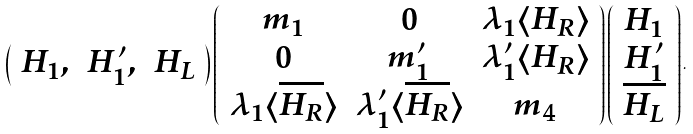Convert formula to latex. <formula><loc_0><loc_0><loc_500><loc_500>\left ( \begin{array} { c c c } H _ { 1 } , & H _ { 1 } ^ { \prime } , & H _ { L } \end{array} \right ) \left ( \begin{array} { c c c } m _ { 1 } & 0 & \lambda _ { 1 } \langle H _ { R } \rangle \\ 0 & m _ { 1 } ^ { \prime } & \lambda _ { 1 } ^ { \prime } \langle H _ { R } \rangle \\ \lambda _ { 1 } \langle \overline { H _ { R } } \rangle & \lambda _ { 1 } ^ { \prime } \langle \overline { H _ { R } } \rangle & m _ { 4 } \end{array} \right ) \left ( \begin{array} { c } H _ { 1 } \\ H _ { 1 } ^ { \prime } \\ \overline { H _ { L } } \end{array} \right ) .</formula> 